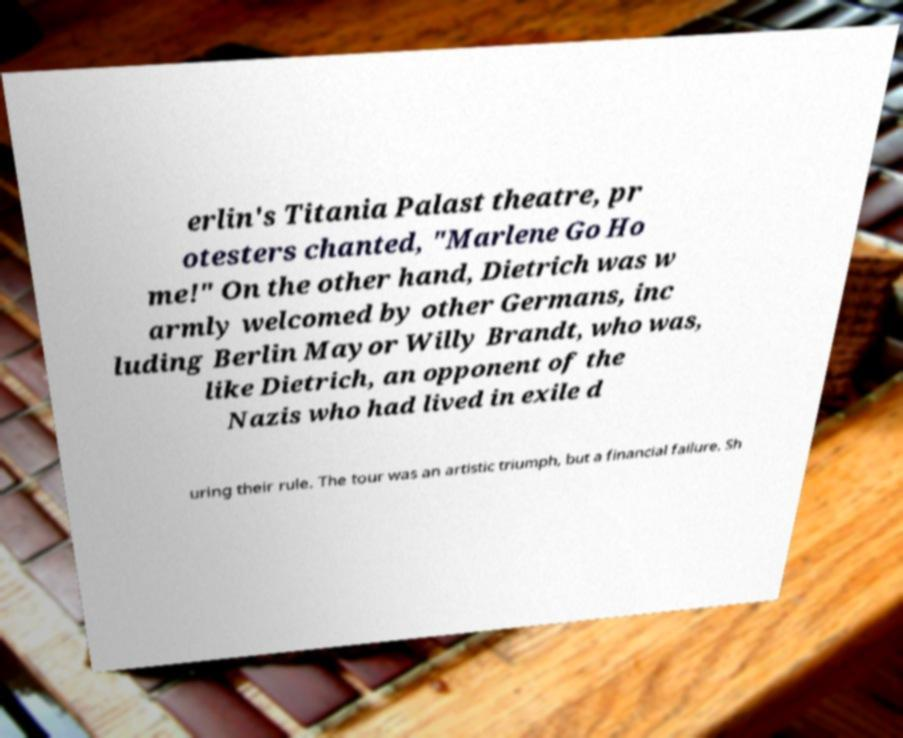Can you read and provide the text displayed in the image?This photo seems to have some interesting text. Can you extract and type it out for me? erlin's Titania Palast theatre, pr otesters chanted, "Marlene Go Ho me!" On the other hand, Dietrich was w armly welcomed by other Germans, inc luding Berlin Mayor Willy Brandt, who was, like Dietrich, an opponent of the Nazis who had lived in exile d uring their rule. The tour was an artistic triumph, but a financial failure. Sh 